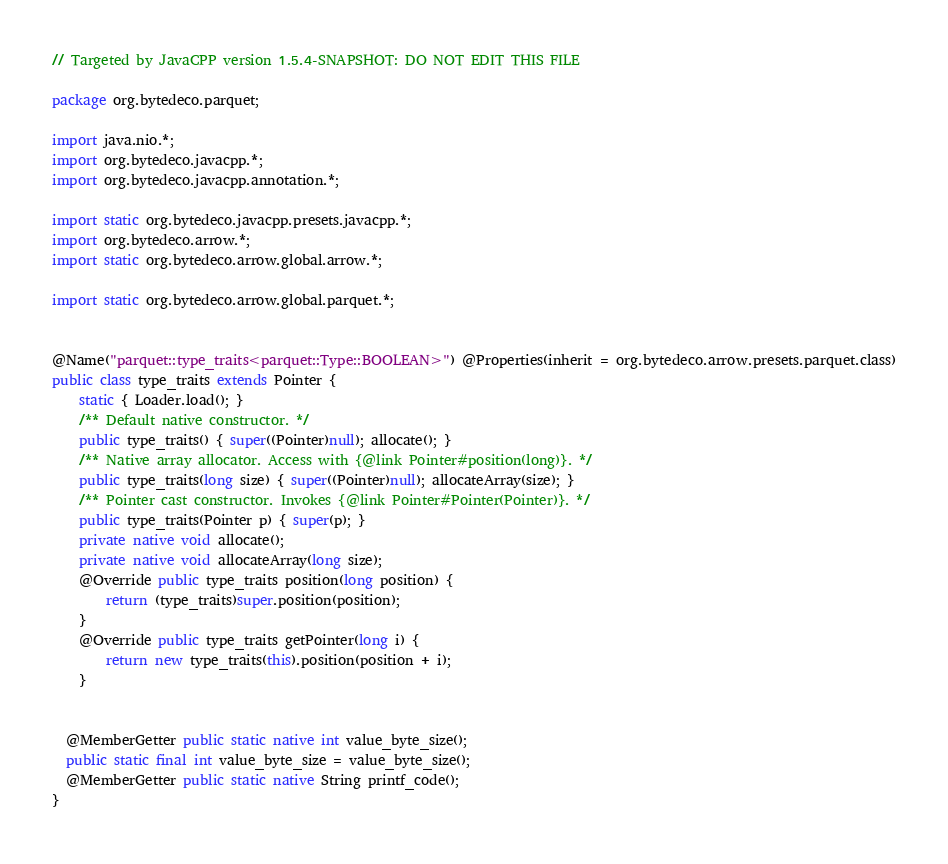<code> <loc_0><loc_0><loc_500><loc_500><_Java_>// Targeted by JavaCPP version 1.5.4-SNAPSHOT: DO NOT EDIT THIS FILE

package org.bytedeco.parquet;

import java.nio.*;
import org.bytedeco.javacpp.*;
import org.bytedeco.javacpp.annotation.*;

import static org.bytedeco.javacpp.presets.javacpp.*;
import org.bytedeco.arrow.*;
import static org.bytedeco.arrow.global.arrow.*;

import static org.bytedeco.arrow.global.parquet.*;


@Name("parquet::type_traits<parquet::Type::BOOLEAN>") @Properties(inherit = org.bytedeco.arrow.presets.parquet.class)
public class type_traits extends Pointer {
    static { Loader.load(); }
    /** Default native constructor. */
    public type_traits() { super((Pointer)null); allocate(); }
    /** Native array allocator. Access with {@link Pointer#position(long)}. */
    public type_traits(long size) { super((Pointer)null); allocateArray(size); }
    /** Pointer cast constructor. Invokes {@link Pointer#Pointer(Pointer)}. */
    public type_traits(Pointer p) { super(p); }
    private native void allocate();
    private native void allocateArray(long size);
    @Override public type_traits position(long position) {
        return (type_traits)super.position(position);
    }
    @Override public type_traits getPointer(long i) {
        return new type_traits(this).position(position + i);
    }


  @MemberGetter public static native int value_byte_size();
  public static final int value_byte_size = value_byte_size();
  @MemberGetter public static native String printf_code();
}
</code> 